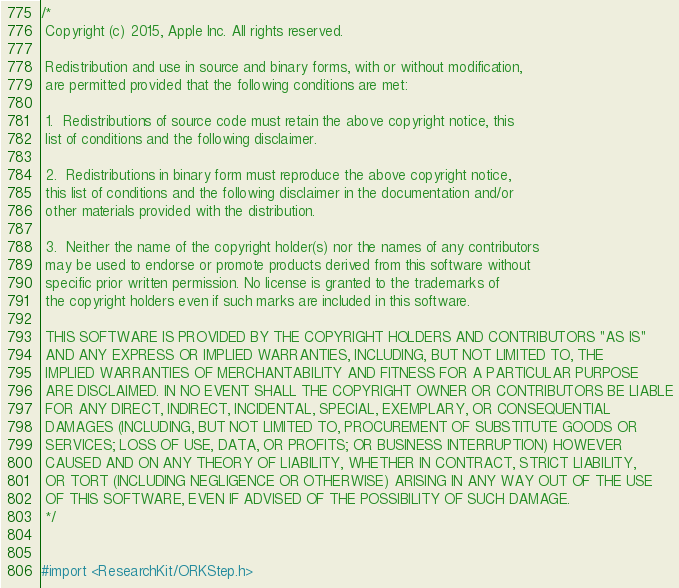Convert code to text. <code><loc_0><loc_0><loc_500><loc_500><_C_>/*
 Copyright (c) 2015, Apple Inc. All rights reserved.
 
 Redistribution and use in source and binary forms, with or without modification,
 are permitted provided that the following conditions are met:
 
 1.  Redistributions of source code must retain the above copyright notice, this
 list of conditions and the following disclaimer.
 
 2.  Redistributions in binary form must reproduce the above copyright notice,
 this list of conditions and the following disclaimer in the documentation and/or
 other materials provided with the distribution.
 
 3.  Neither the name of the copyright holder(s) nor the names of any contributors
 may be used to endorse or promote products derived from this software without
 specific prior written permission. No license is granted to the trademarks of
 the copyright holders even if such marks are included in this software.
 
 THIS SOFTWARE IS PROVIDED BY THE COPYRIGHT HOLDERS AND CONTRIBUTORS "AS IS"
 AND ANY EXPRESS OR IMPLIED WARRANTIES, INCLUDING, BUT NOT LIMITED TO, THE
 IMPLIED WARRANTIES OF MERCHANTABILITY AND FITNESS FOR A PARTICULAR PURPOSE
 ARE DISCLAIMED. IN NO EVENT SHALL THE COPYRIGHT OWNER OR CONTRIBUTORS BE LIABLE
 FOR ANY DIRECT, INDIRECT, INCIDENTAL, SPECIAL, EXEMPLARY, OR CONSEQUENTIAL
 DAMAGES (INCLUDING, BUT NOT LIMITED TO, PROCUREMENT OF SUBSTITUTE GOODS OR
 SERVICES; LOSS OF USE, DATA, OR PROFITS; OR BUSINESS INTERRUPTION) HOWEVER
 CAUSED AND ON ANY THEORY OF LIABILITY, WHETHER IN CONTRACT, STRICT LIABILITY,
 OR TORT (INCLUDING NEGLIGENCE OR OTHERWISE) ARISING IN ANY WAY OUT OF THE USE
 OF THIS SOFTWARE, EVEN IF ADVISED OF THE POSSIBILITY OF SUCH DAMAGE.
 */


#import <ResearchKit/ORKStep.h>

</code> 